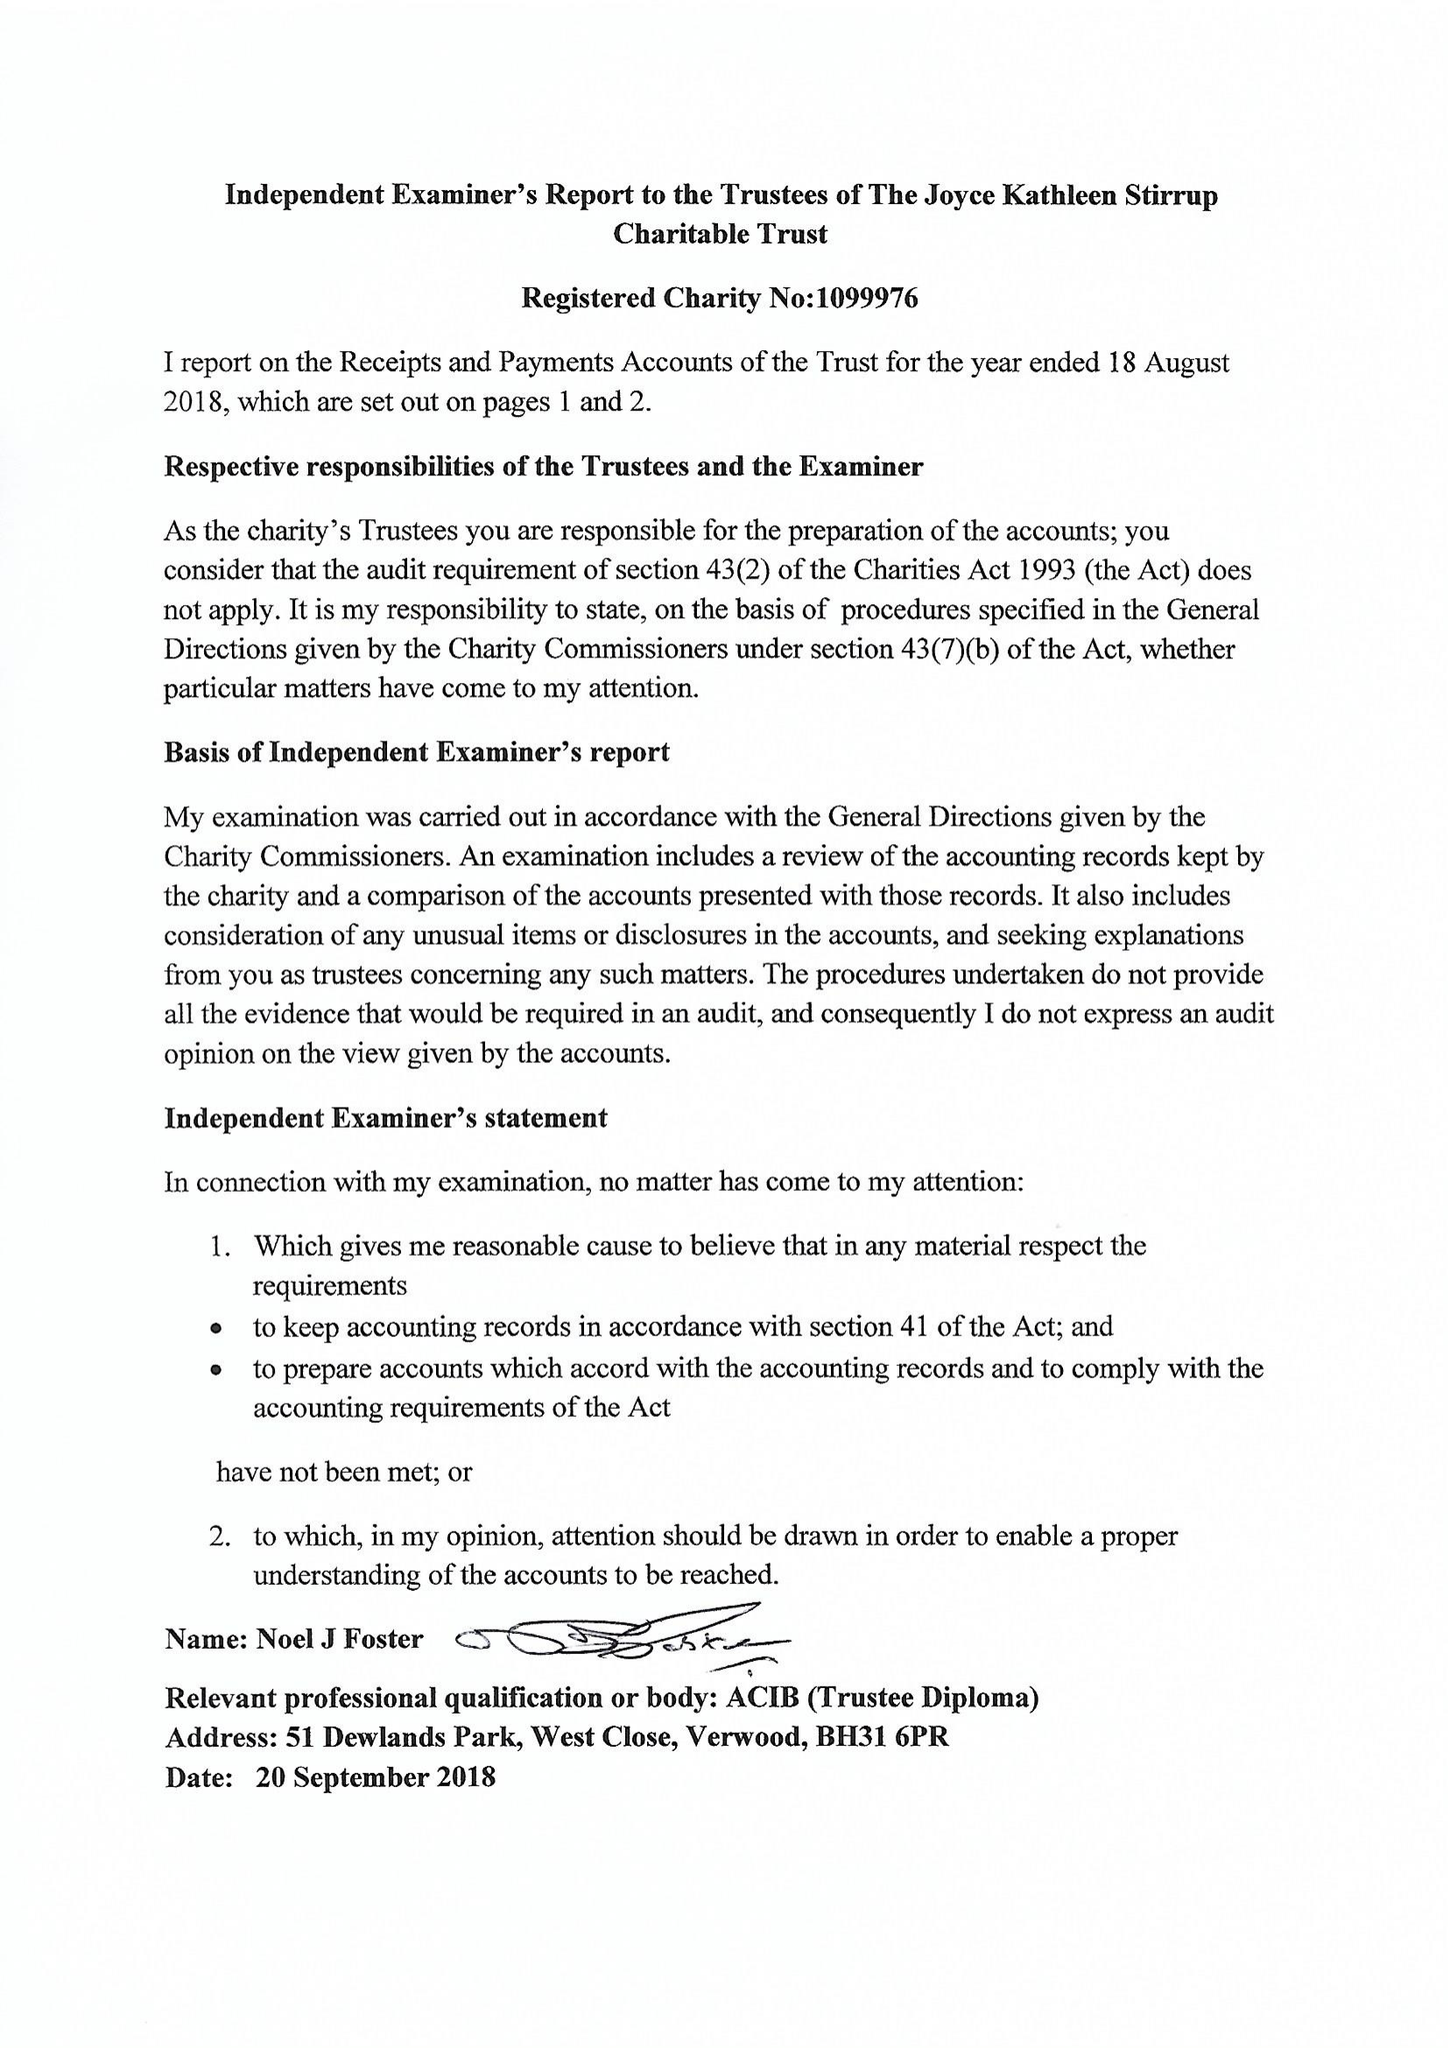What is the value for the spending_annually_in_british_pounds?
Answer the question using a single word or phrase. 130232.00 